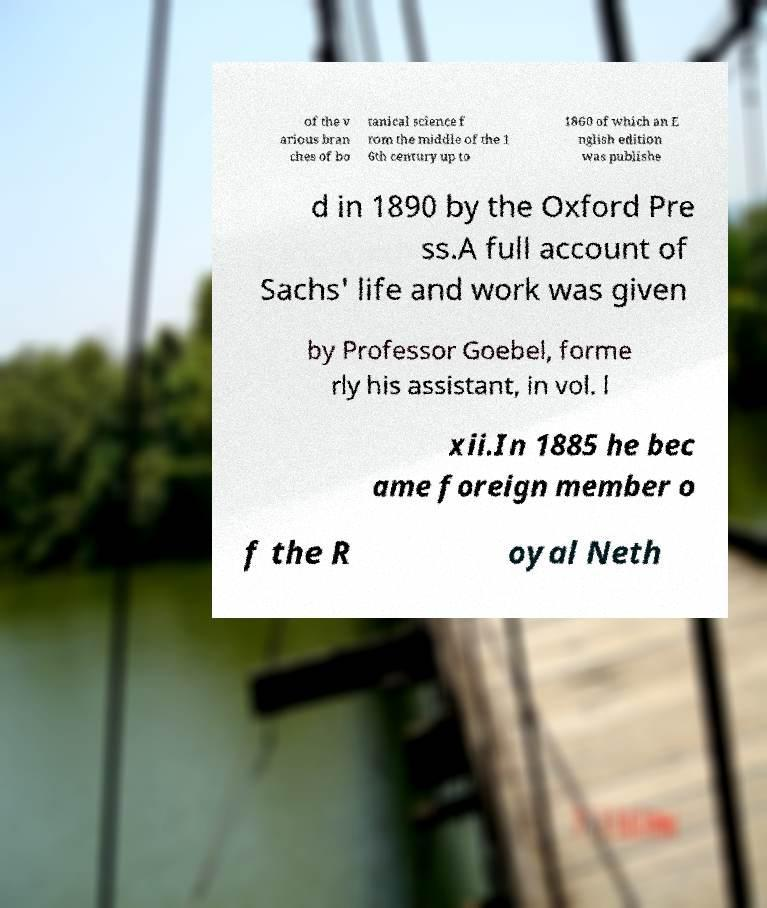I need the written content from this picture converted into text. Can you do that? of the v arious bran ches of bo tanical science f rom the middle of the 1 6th century up to 1860 of which an E nglish edition was publishe d in 1890 by the Oxford Pre ss.A full account of Sachs' life and work was given by Professor Goebel, forme rly his assistant, in vol. l xii.In 1885 he bec ame foreign member o f the R oyal Neth 